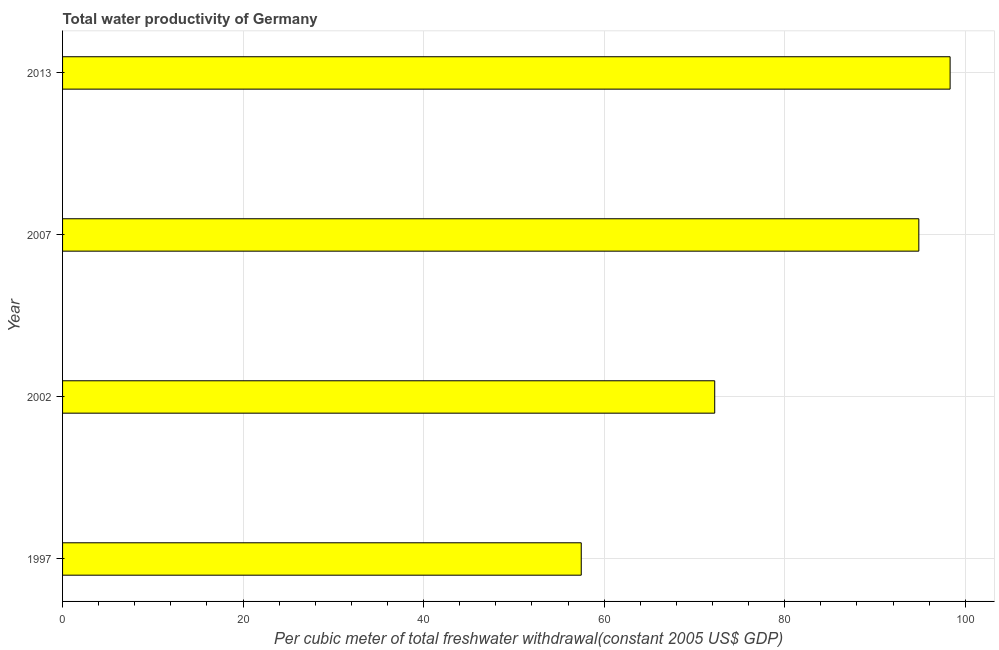Does the graph contain grids?
Provide a succinct answer. Yes. What is the title of the graph?
Your answer should be very brief. Total water productivity of Germany. What is the label or title of the X-axis?
Ensure brevity in your answer.  Per cubic meter of total freshwater withdrawal(constant 2005 US$ GDP). What is the total water productivity in 2013?
Give a very brief answer. 98.33. Across all years, what is the maximum total water productivity?
Make the answer very short. 98.33. Across all years, what is the minimum total water productivity?
Give a very brief answer. 57.46. In which year was the total water productivity maximum?
Offer a terse response. 2013. In which year was the total water productivity minimum?
Provide a short and direct response. 1997. What is the sum of the total water productivity?
Provide a short and direct response. 322.9. What is the difference between the total water productivity in 2002 and 2007?
Keep it short and to the point. -22.61. What is the average total water productivity per year?
Make the answer very short. 80.73. What is the median total water productivity?
Your answer should be very brief. 83.56. What is the ratio of the total water productivity in 1997 to that in 2002?
Ensure brevity in your answer.  0.8. Is the difference between the total water productivity in 2002 and 2013 greater than the difference between any two years?
Your answer should be very brief. No. What is the difference between the highest and the second highest total water productivity?
Give a very brief answer. 3.47. What is the difference between the highest and the lowest total water productivity?
Give a very brief answer. 40.87. How many bars are there?
Your response must be concise. 4. What is the difference between two consecutive major ticks on the X-axis?
Provide a succinct answer. 20. What is the Per cubic meter of total freshwater withdrawal(constant 2005 US$ GDP) in 1997?
Your response must be concise. 57.46. What is the Per cubic meter of total freshwater withdrawal(constant 2005 US$ GDP) of 2002?
Offer a very short reply. 72.25. What is the Per cubic meter of total freshwater withdrawal(constant 2005 US$ GDP) in 2007?
Keep it short and to the point. 94.86. What is the Per cubic meter of total freshwater withdrawal(constant 2005 US$ GDP) in 2013?
Make the answer very short. 98.33. What is the difference between the Per cubic meter of total freshwater withdrawal(constant 2005 US$ GDP) in 1997 and 2002?
Provide a succinct answer. -14.79. What is the difference between the Per cubic meter of total freshwater withdrawal(constant 2005 US$ GDP) in 1997 and 2007?
Offer a very short reply. -37.4. What is the difference between the Per cubic meter of total freshwater withdrawal(constant 2005 US$ GDP) in 1997 and 2013?
Your response must be concise. -40.87. What is the difference between the Per cubic meter of total freshwater withdrawal(constant 2005 US$ GDP) in 2002 and 2007?
Make the answer very short. -22.61. What is the difference between the Per cubic meter of total freshwater withdrawal(constant 2005 US$ GDP) in 2002 and 2013?
Your answer should be very brief. -26.08. What is the difference between the Per cubic meter of total freshwater withdrawal(constant 2005 US$ GDP) in 2007 and 2013?
Provide a succinct answer. -3.47. What is the ratio of the Per cubic meter of total freshwater withdrawal(constant 2005 US$ GDP) in 1997 to that in 2002?
Offer a very short reply. 0.8. What is the ratio of the Per cubic meter of total freshwater withdrawal(constant 2005 US$ GDP) in 1997 to that in 2007?
Provide a succinct answer. 0.61. What is the ratio of the Per cubic meter of total freshwater withdrawal(constant 2005 US$ GDP) in 1997 to that in 2013?
Keep it short and to the point. 0.58. What is the ratio of the Per cubic meter of total freshwater withdrawal(constant 2005 US$ GDP) in 2002 to that in 2007?
Ensure brevity in your answer.  0.76. What is the ratio of the Per cubic meter of total freshwater withdrawal(constant 2005 US$ GDP) in 2002 to that in 2013?
Your answer should be very brief. 0.73. What is the ratio of the Per cubic meter of total freshwater withdrawal(constant 2005 US$ GDP) in 2007 to that in 2013?
Your response must be concise. 0.96. 